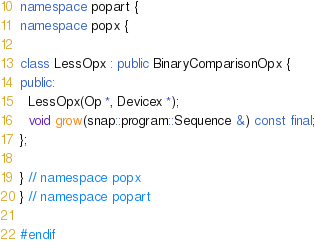<code> <loc_0><loc_0><loc_500><loc_500><_C++_>namespace popart {
namespace popx {

class LessOpx : public BinaryComparisonOpx {
public:
  LessOpx(Op *, Devicex *);
  void grow(snap::program::Sequence &) const final;
};

} // namespace popx
} // namespace popart

#endif
</code> 